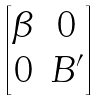Convert formula to latex. <formula><loc_0><loc_0><loc_500><loc_500>\begin{bmatrix} \beta & 0 \\ 0 & B ^ { \prime } \end{bmatrix}</formula> 